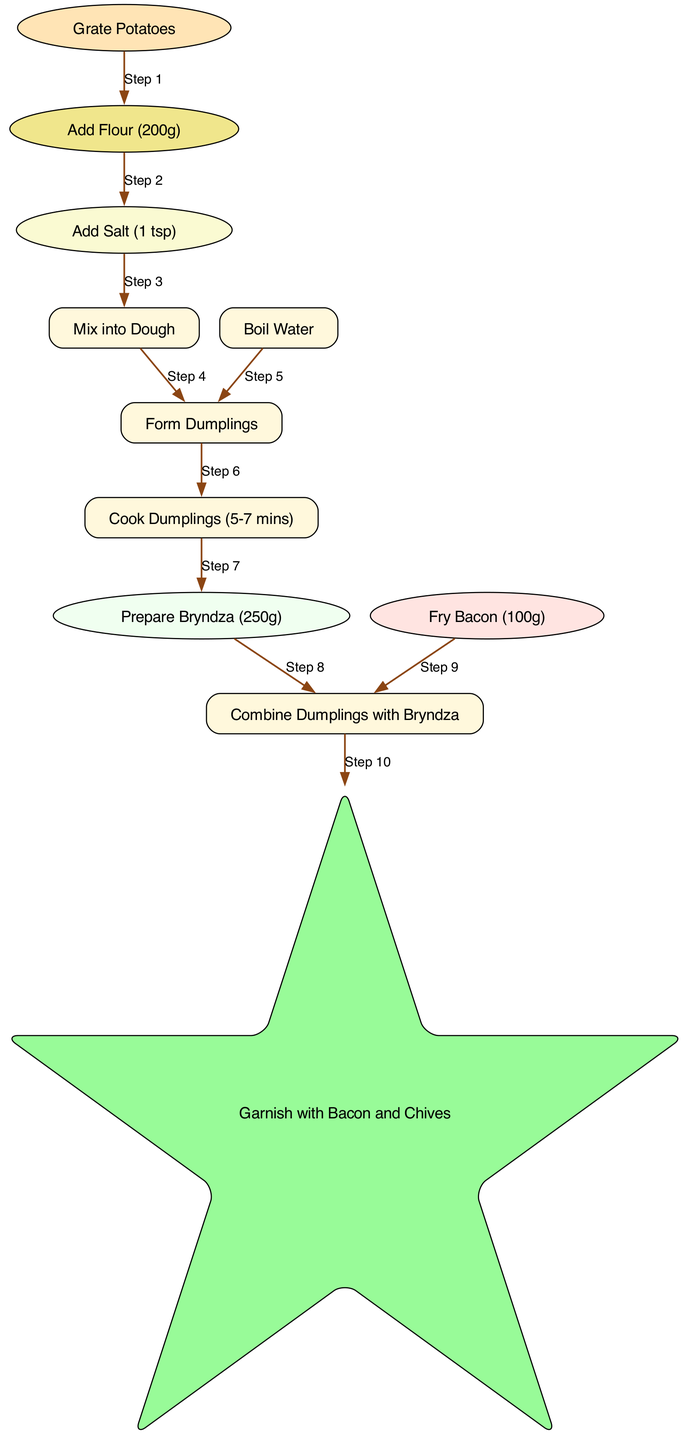What is the first step in the process? The first node in the diagram is "Grate Potatoes," indicating that this is the initial action to be taken in the recipe.
Answer: Grate Potatoes How many ingredients need to be added before mixing into dough? According to the diagram, after grating potatoes, flour and salt are added, which means two ingredients are added before the dough mixing step.
Answer: 2 What is the cooking time for the dumplings? The node "Cook Dumplings" specifies that the cooking time is between 5 to 7 minutes, as indicated in the diagram.
Answer: 5-7 mins What step comes after forming the dumplings? The arrow from "Form Dumplings" leads to "Cook Dumplings," indicating that this is the next step in the process.
Answer: Cook Dumplings What are the two ingredients to prepare before combining with dumplings? The diagram has two nodes, "Prepare Bryndza" and "Fry Bacon," both of which must be done before they can be combined with the dumplings.
Answer: Bryndza and Bacon How is the final dish garnished? The last step in the diagram is "Garnish with Bacon and Chives," which indicates how the dish is finished before serving.
Answer: Bacon and Chives Which ingredient is added at Step 2? The second node in the sequence is "Add Flour (200g)," showing that flour is the ingredient added at this step.
Answer: Flour (200g) What step is associated with the preparation of Bryndza? The diagram shows that "Prepare Bryndza (250g)" is the step that directly follows the cooking of dumplings, indicating its relevance in the process.
Answer: Prepare Bryndza (250g) How many total steps are there in the cooking process? By counting the edges in the diagram, there are ten steps that outline the process of making the dish from start to finish.
Answer: 10 